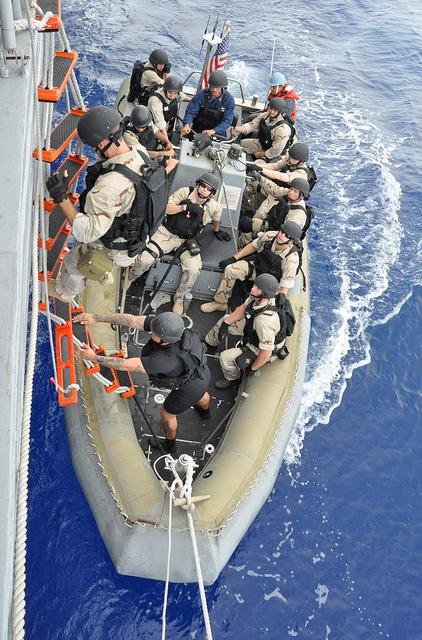Where is the flag from?
Keep it brief. Usa. What are the people wearing on their heads?
Keep it brief. Helmets. Could this be a military exercise?
Answer briefly. Yes. Is the man in front looking up?
Concise answer only. No. 